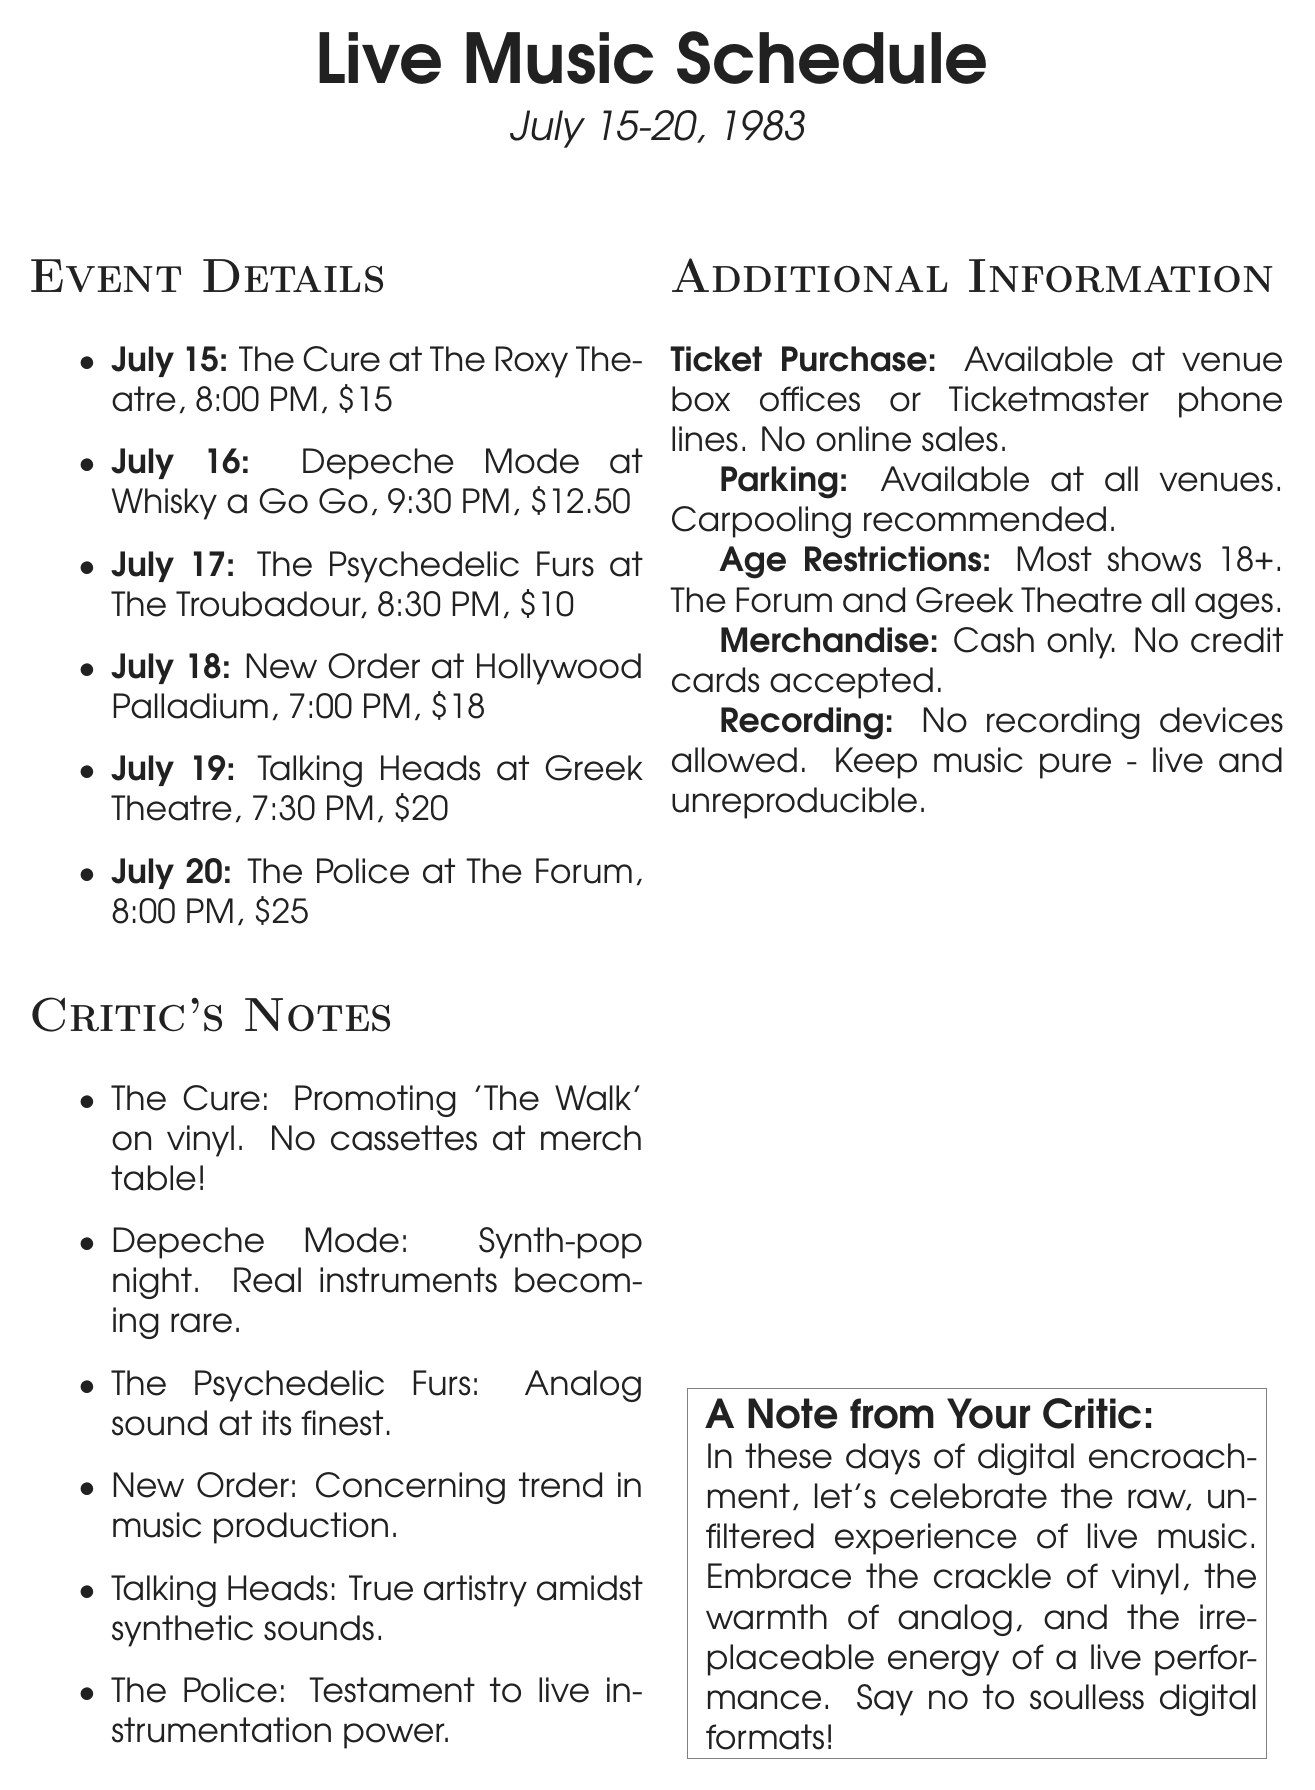What is the date of The Cure's performance? The performance of The Cure is scheduled for July 15, 1983.
Answer: July 15 What is the ticket price for Talking Heads? The ticket price for Talking Heads at the Greek Theatre is noted in the document.
Answer: $20 Where is Depeche Mode performing? The venue for Depeche Mode's performance is specified in the document.
Answer: Whisky a Go Go What is the time of New Order's show? The document states the start time for New Order's show at the Hollywood Palladium.
Answer: 7:00 PM Which artist is performing at The Forum? The document specifically names the artist performing at The Forum on July 20.
Answer: The Police What is the age restriction for most shows? The document mentions the age restriction overall for most performances.
Answer: 18+ What type of music does The Psychedelic Furs represent? The document describes The Psychedelic Furs' music style as analog sound.
Answer: Analog sound How are tickets sold for these performances? The document provides details on how to purchase tickets for the concerts.
Answer: Venue box offices or Ticketmaster phone lines What is the advised method for parking at the venues? The document suggests a recommended approach for parking at the events.
Answer: Carpooling recommended 